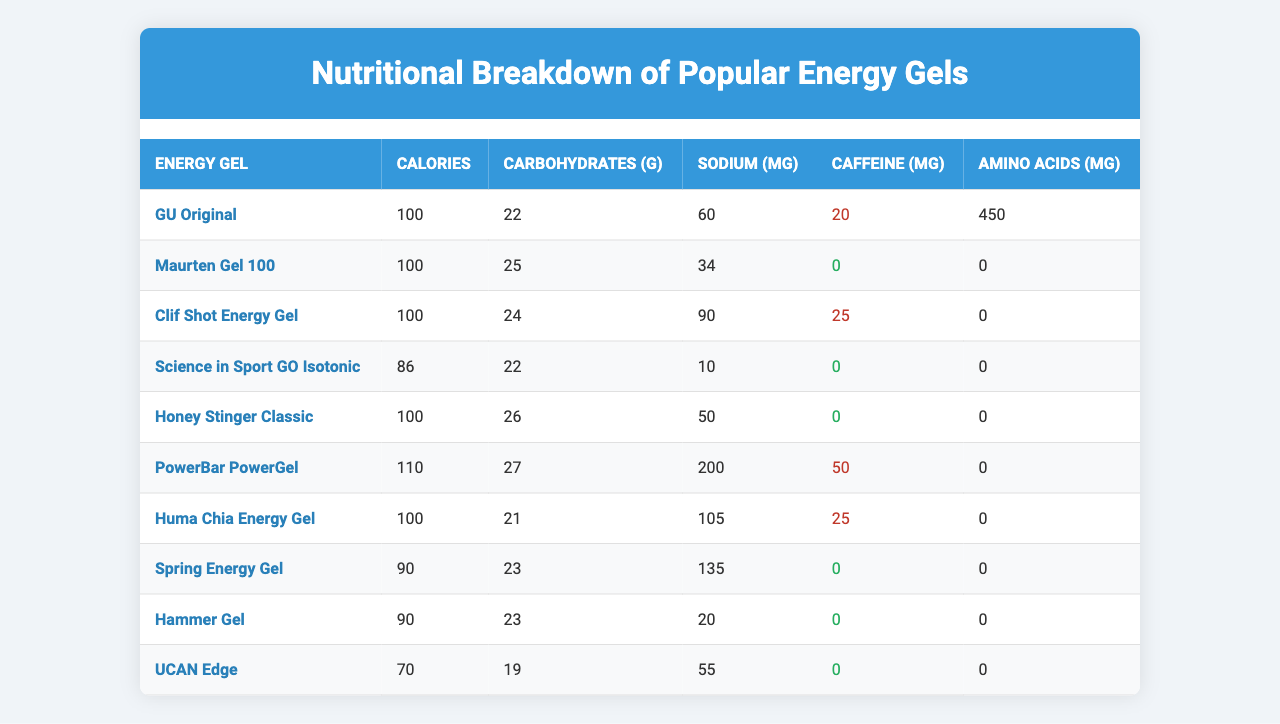What is the caloric content of the PowerBar PowerGel? The table shows that PowerBar PowerGel has a caloric content of 110 calories.
Answer: 110 calories Which energy gel has the highest sodium content? By examining the sodium values in the table, PowerBar PowerGel has the highest sodium content at 200 mg.
Answer: PowerBar PowerGel What is the total amount of carbohydrates in GU Original and Clif Shot Energy Gel? GU Original has 22 grams of carbohydrates, and Clif Shot Energy Gel has 24 grams. Summing these gives 22 + 24 = 46 grams.
Answer: 46 grams Is the caffeine content of Maurten Gel 100 greater than that of Hammer Gel? Maurten Gel 100 has 0 mg of caffeine while Hammer Gel also has 0 mg, so the caffeine content is equal.
Answer: No Which energy gel has the lowest calories? UCAN Edge has the lowest caloric content at 70 calories.
Answer: UCAN Edge How many energy gels contain caffeine? Looking at the caffeine column, GU Original, Clif Shot Energy Gel, and PowerBar PowerGel are the only gels that contain caffeine (indicated by values over 0). Thus, there are 3 gels with caffeine.
Answer: 3 gels What is the average caffeine content of the energy gels listed in the table? The total caffeine content of the energy gels is 20 + 25 + 50 = 95 mg, adding in those with 0 mg caffeine means the average is 95 / 10 = 9.5 mg.
Answer: 9.5 mg Which gel has the most amino acids per serving? GU Original has 450 mg of amino acids, which is more than all others listed.
Answer: GU Original What is the difference in carbohydrate content between HOney Stinger Classic and PowerBar PowerGel? Honey Stinger Classic contains 26 grams of carbohydrates, while PowerBar PowerGel has 27 grams, thus the difference is 27 - 26 = 1 gram.
Answer: 1 gram Does Science in Sport GO Isotonic have a higher sodium content than Huma Chia Energy Gel? Science in Sport GO Isotonic has 10 mg of sodium and Huma Chia Energy Gel has 105 mg; therefore, Science in Sport GO Isotonic has a lower sodium content.
Answer: No 